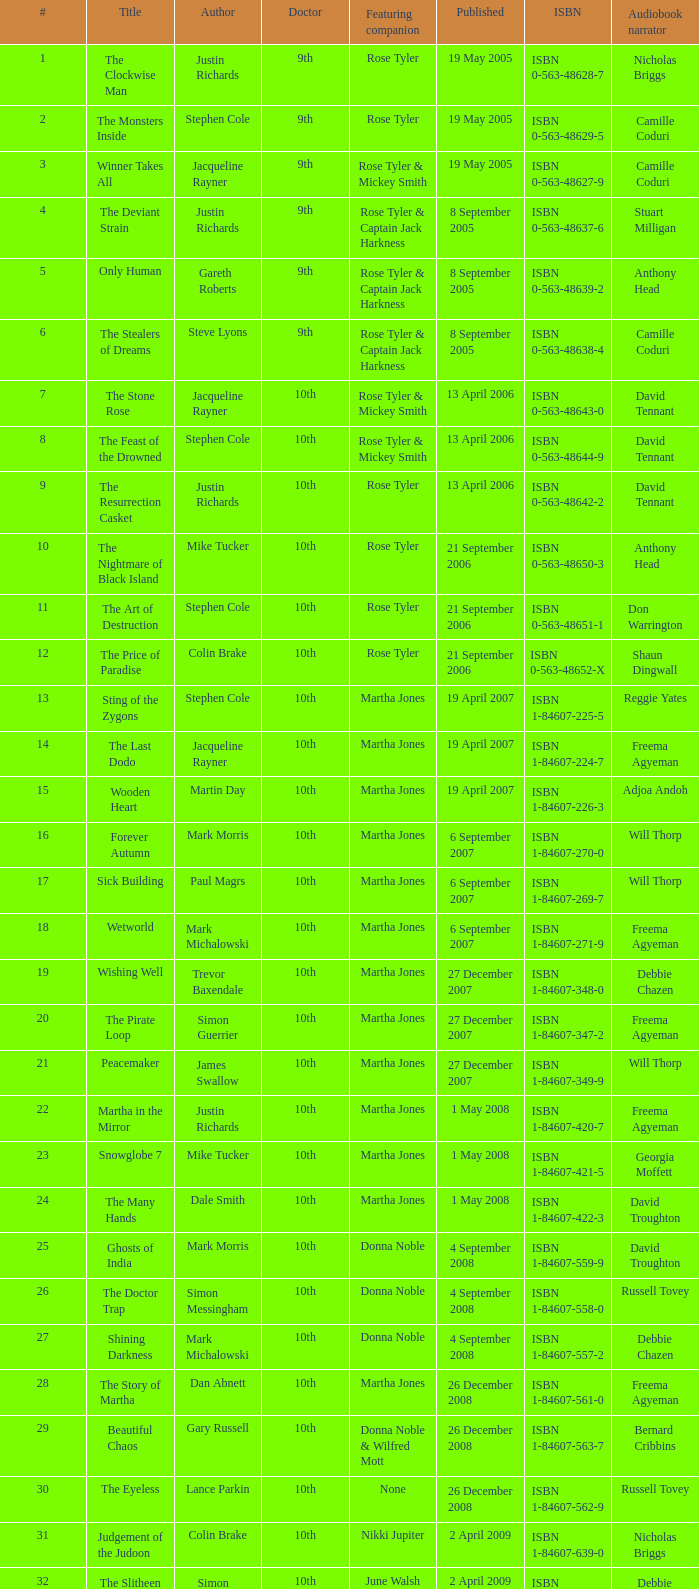What is the title of ISBN 1-84990-243-7? The Silent Stars Go By. Parse the table in full. {'header': ['#', 'Title', 'Author', 'Doctor', 'Featuring companion', 'Published', 'ISBN', 'Audiobook narrator'], 'rows': [['1', 'The Clockwise Man', 'Justin Richards', '9th', 'Rose Tyler', '19 May 2005', 'ISBN 0-563-48628-7', 'Nicholas Briggs'], ['2', 'The Monsters Inside', 'Stephen Cole', '9th', 'Rose Tyler', '19 May 2005', 'ISBN 0-563-48629-5', 'Camille Coduri'], ['3', 'Winner Takes All', 'Jacqueline Rayner', '9th', 'Rose Tyler & Mickey Smith', '19 May 2005', 'ISBN 0-563-48627-9', 'Camille Coduri'], ['4', 'The Deviant Strain', 'Justin Richards', '9th', 'Rose Tyler & Captain Jack Harkness', '8 September 2005', 'ISBN 0-563-48637-6', 'Stuart Milligan'], ['5', 'Only Human', 'Gareth Roberts', '9th', 'Rose Tyler & Captain Jack Harkness', '8 September 2005', 'ISBN 0-563-48639-2', 'Anthony Head'], ['6', 'The Stealers of Dreams', 'Steve Lyons', '9th', 'Rose Tyler & Captain Jack Harkness', '8 September 2005', 'ISBN 0-563-48638-4', 'Camille Coduri'], ['7', 'The Stone Rose', 'Jacqueline Rayner', '10th', 'Rose Tyler & Mickey Smith', '13 April 2006', 'ISBN 0-563-48643-0', 'David Tennant'], ['8', 'The Feast of the Drowned', 'Stephen Cole', '10th', 'Rose Tyler & Mickey Smith', '13 April 2006', 'ISBN 0-563-48644-9', 'David Tennant'], ['9', 'The Resurrection Casket', 'Justin Richards', '10th', 'Rose Tyler', '13 April 2006', 'ISBN 0-563-48642-2', 'David Tennant'], ['10', 'The Nightmare of Black Island', 'Mike Tucker', '10th', 'Rose Tyler', '21 September 2006', 'ISBN 0-563-48650-3', 'Anthony Head'], ['11', 'The Art of Destruction', 'Stephen Cole', '10th', 'Rose Tyler', '21 September 2006', 'ISBN 0-563-48651-1', 'Don Warrington'], ['12', 'The Price of Paradise', 'Colin Brake', '10th', 'Rose Tyler', '21 September 2006', 'ISBN 0-563-48652-X', 'Shaun Dingwall'], ['13', 'Sting of the Zygons', 'Stephen Cole', '10th', 'Martha Jones', '19 April 2007', 'ISBN 1-84607-225-5', 'Reggie Yates'], ['14', 'The Last Dodo', 'Jacqueline Rayner', '10th', 'Martha Jones', '19 April 2007', 'ISBN 1-84607-224-7', 'Freema Agyeman'], ['15', 'Wooden Heart', 'Martin Day', '10th', 'Martha Jones', '19 April 2007', 'ISBN 1-84607-226-3', 'Adjoa Andoh'], ['16', 'Forever Autumn', 'Mark Morris', '10th', 'Martha Jones', '6 September 2007', 'ISBN 1-84607-270-0', 'Will Thorp'], ['17', 'Sick Building', 'Paul Magrs', '10th', 'Martha Jones', '6 September 2007', 'ISBN 1-84607-269-7', 'Will Thorp'], ['18', 'Wetworld', 'Mark Michalowski', '10th', 'Martha Jones', '6 September 2007', 'ISBN 1-84607-271-9', 'Freema Agyeman'], ['19', 'Wishing Well', 'Trevor Baxendale', '10th', 'Martha Jones', '27 December 2007', 'ISBN 1-84607-348-0', 'Debbie Chazen'], ['20', 'The Pirate Loop', 'Simon Guerrier', '10th', 'Martha Jones', '27 December 2007', 'ISBN 1-84607-347-2', 'Freema Agyeman'], ['21', 'Peacemaker', 'James Swallow', '10th', 'Martha Jones', '27 December 2007', 'ISBN 1-84607-349-9', 'Will Thorp'], ['22', 'Martha in the Mirror', 'Justin Richards', '10th', 'Martha Jones', '1 May 2008', 'ISBN 1-84607-420-7', 'Freema Agyeman'], ['23', 'Snowglobe 7', 'Mike Tucker', '10th', 'Martha Jones', '1 May 2008', 'ISBN 1-84607-421-5', 'Georgia Moffett'], ['24', 'The Many Hands', 'Dale Smith', '10th', 'Martha Jones', '1 May 2008', 'ISBN 1-84607-422-3', 'David Troughton'], ['25', 'Ghosts of India', 'Mark Morris', '10th', 'Donna Noble', '4 September 2008', 'ISBN 1-84607-559-9', 'David Troughton'], ['26', 'The Doctor Trap', 'Simon Messingham', '10th', 'Donna Noble', '4 September 2008', 'ISBN 1-84607-558-0', 'Russell Tovey'], ['27', 'Shining Darkness', 'Mark Michalowski', '10th', 'Donna Noble', '4 September 2008', 'ISBN 1-84607-557-2', 'Debbie Chazen'], ['28', 'The Story of Martha', 'Dan Abnett', '10th', 'Martha Jones', '26 December 2008', 'ISBN 1-84607-561-0', 'Freema Agyeman'], ['29', 'Beautiful Chaos', 'Gary Russell', '10th', 'Donna Noble & Wilfred Mott', '26 December 2008', 'ISBN 1-84607-563-7', 'Bernard Cribbins'], ['30', 'The Eyeless', 'Lance Parkin', '10th', 'None', '26 December 2008', 'ISBN 1-84607-562-9', 'Russell Tovey'], ['31', 'Judgement of the Judoon', 'Colin Brake', '10th', 'Nikki Jupiter', '2 April 2009', 'ISBN 1-84607-639-0', 'Nicholas Briggs'], ['32', 'The Slitheen Excursion', 'Simon Guerrier', '10th', 'June Walsh', '2 April 2009', 'ISBN 1-84607-640-4', 'Debbie Chazen'], ['33', 'Prisoner of the Daleks', 'Trevor Baxendale', '10th', 'Jon Bowman', '2 April 2009', 'ISBN 1-84607-641-2', 'Nicholas Briggs'], ['34', 'The Taking of Chelsea 426', 'David Llewellyn', '10th', 'Jake & Vienna Carstairs', '17 September 2009', 'ISBN 1-84607-758-3', 'Christopher Ryan'], ['35', 'Autonomy', 'Daniel Blythe', '10th', 'Kate Maguire', '17 September 2009', 'ISBN 1-84607-759-1', 'Georgia Moffett'], ['36', 'The Krillitane Storm', 'Christopher Cooper', '10th', 'Emily Parr', '17 September 2009', 'ISBN 1-84607-761-3', 'Will Thorp'], ['37', 'Apollo 23', 'Justin Richards', '11th', 'Amy Pond', '22 April 2010', 'ISBN 1-84607-200-X', 'James Albrecht'], ['38', 'Night of the Humans', 'David Llewellyn', '11th', 'Amy Pond', '22 April 2010', 'ISBN 1-84607-969-1', 'Arthur Darvill'], ['39', 'The Forgotten Army', 'Brian Minchin', '11th', 'Amy Pond', '22 April 2010', 'ISBN 1-84607-987-X', 'Olivia Colman'], ['40', 'Nuclear Time', 'Oli Smith', '11th', 'Amy Pond & Rory Williams', '8 July 2010', 'ISBN 1-84607-989-6', 'Nicholas Briggs'], ['41', "The King's Dragon", 'Una McCormack', '11th', 'Amy Pond & Rory Williams', '8 July 2010', 'ISBN 1-84607-990-X', 'Nicholas Briggs'], ['42', 'The Glamour Chase', 'Gary Russell', '11th', 'Amy Pond & Rory Williams', '8 July 2010', 'ISBN 1-84607-988-8', 'Arthur Darvill'], ['S1', 'The Coming of the Terraphiles', 'Michael Moorcock', '11th', 'Amy Pond', '14 October 2010', 'ISBN 1-84607-983-7', 'Clive Mantle'], ['43', 'Dead of Winter', 'James Goss', '11th', 'Amy Pond & Rory Williams', '28 April 2011', 'ISBN 1-84990-238-0', 'Clare Corbett'], ['44', 'The Way Through the Woods', 'Una McCormack', '11th', 'Amy Pond & Rory Williams', '28 April 2011', 'ISBN 1-84990-237-2', 'Clare Corbett'], ['45', "Hunter's Moon", 'Paul Finch', '11th', 'Amy Pond & Rory Williams', '28 April 2011', 'ISBN 1-84990-236-4', 'Arthur Darvill'], ['46', 'Touched by an Angel', 'Jonathan Morris', '11th', 'Amy Pond & Rory Williams', '23 June 2011', 'ISBN 1-84990-234-8', 'Clare Corbett'], ['47', 'Paradox Lost', 'George Mann', '11th', 'Amy Pond & Rory Williams', '23 June 2011', 'ISBN 1-84990-235-6', 'Nicholas Briggs'], ['48', 'Borrowed Time', 'Naomi Alderman', '11th', 'Amy Pond & Rory Williams', '23 June 2011', 'ISBN 1-84990-233-X', 'Meera Syal'], ['S2', 'The Silent Stars Go By', 'Dan Abnett', '11th', 'Amy Pond & Rory Williams', '29 September 2011', 'ISBN 1-84990-243-7', 'Michael Maloney'], ['S3', 'Dark Horizons', 'J T Colgan', '11th', 'None', '7 July 2012', 'ISBN 1-84990-456-1', 'Neve McIntosh']]} 